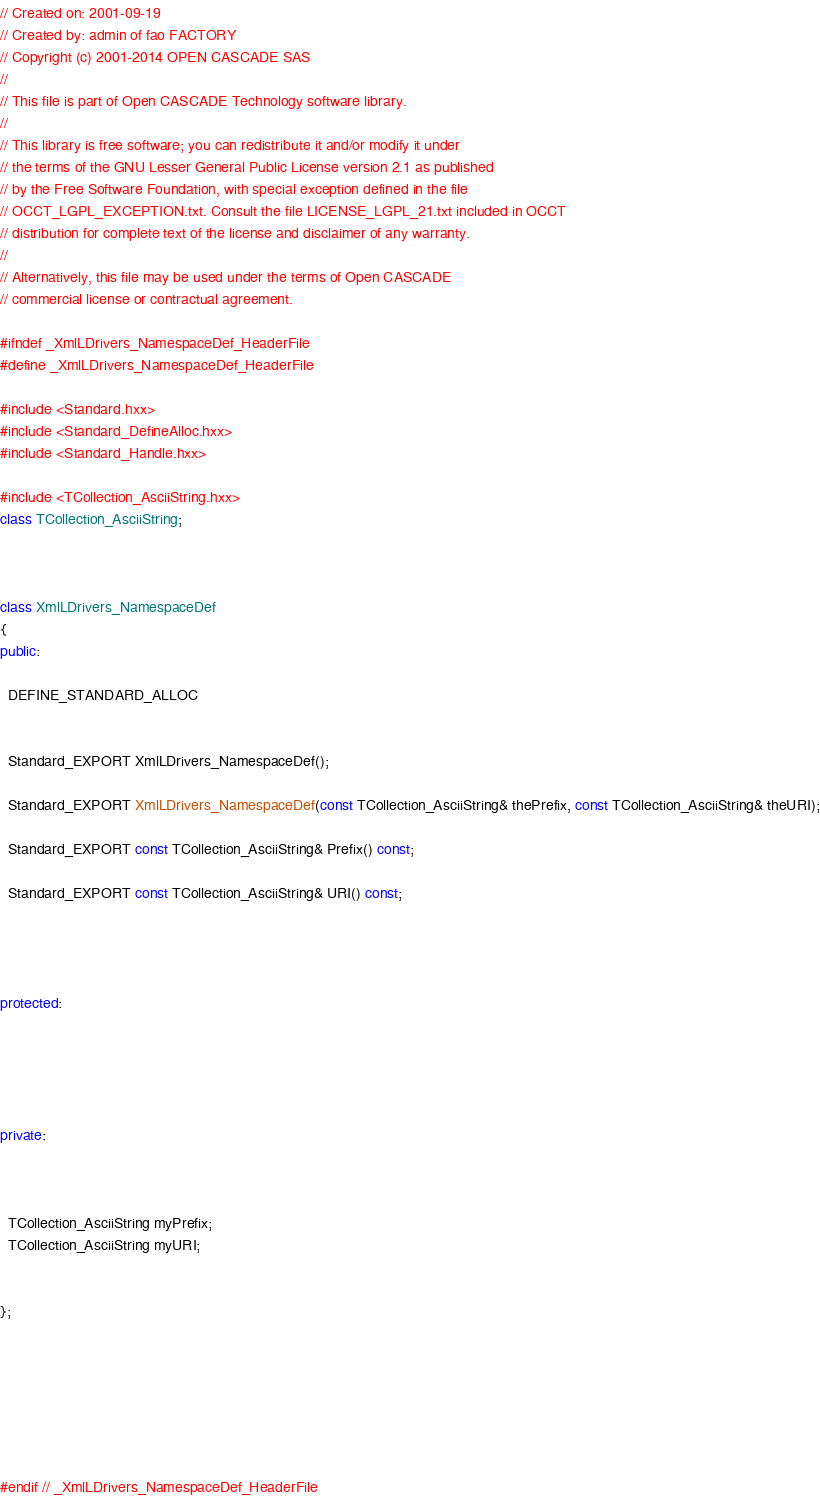<code> <loc_0><loc_0><loc_500><loc_500><_C++_>// Created on: 2001-09-19
// Created by: admin of fao FACTORY
// Copyright (c) 2001-2014 OPEN CASCADE SAS
//
// This file is part of Open CASCADE Technology software library.
//
// This library is free software; you can redistribute it and/or modify it under
// the terms of the GNU Lesser General Public License version 2.1 as published
// by the Free Software Foundation, with special exception defined in the file
// OCCT_LGPL_EXCEPTION.txt. Consult the file LICENSE_LGPL_21.txt included in OCCT
// distribution for complete text of the license and disclaimer of any warranty.
//
// Alternatively, this file may be used under the terms of Open CASCADE
// commercial license or contractual agreement.

#ifndef _XmlLDrivers_NamespaceDef_HeaderFile
#define _XmlLDrivers_NamespaceDef_HeaderFile

#include <Standard.hxx>
#include <Standard_DefineAlloc.hxx>
#include <Standard_Handle.hxx>

#include <TCollection_AsciiString.hxx>
class TCollection_AsciiString;



class XmlLDrivers_NamespaceDef 
{
public:

  DEFINE_STANDARD_ALLOC

  
  Standard_EXPORT XmlLDrivers_NamespaceDef();
  
  Standard_EXPORT XmlLDrivers_NamespaceDef(const TCollection_AsciiString& thePrefix, const TCollection_AsciiString& theURI);
  
  Standard_EXPORT const TCollection_AsciiString& Prefix() const;
  
  Standard_EXPORT const TCollection_AsciiString& URI() const;




protected:





private:



  TCollection_AsciiString myPrefix;
  TCollection_AsciiString myURI;


};







#endif // _XmlLDrivers_NamespaceDef_HeaderFile
</code> 